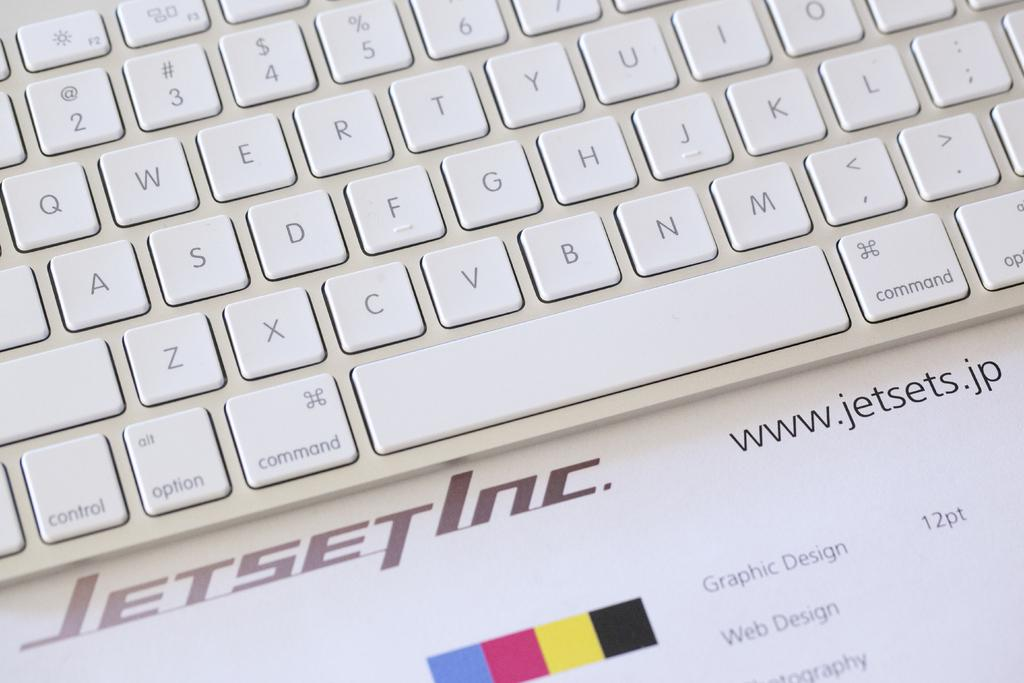<image>
Share a concise interpretation of the image provided. Jetset Inc., Graphic Design 12pt is listed on the paper below the keyboard. 